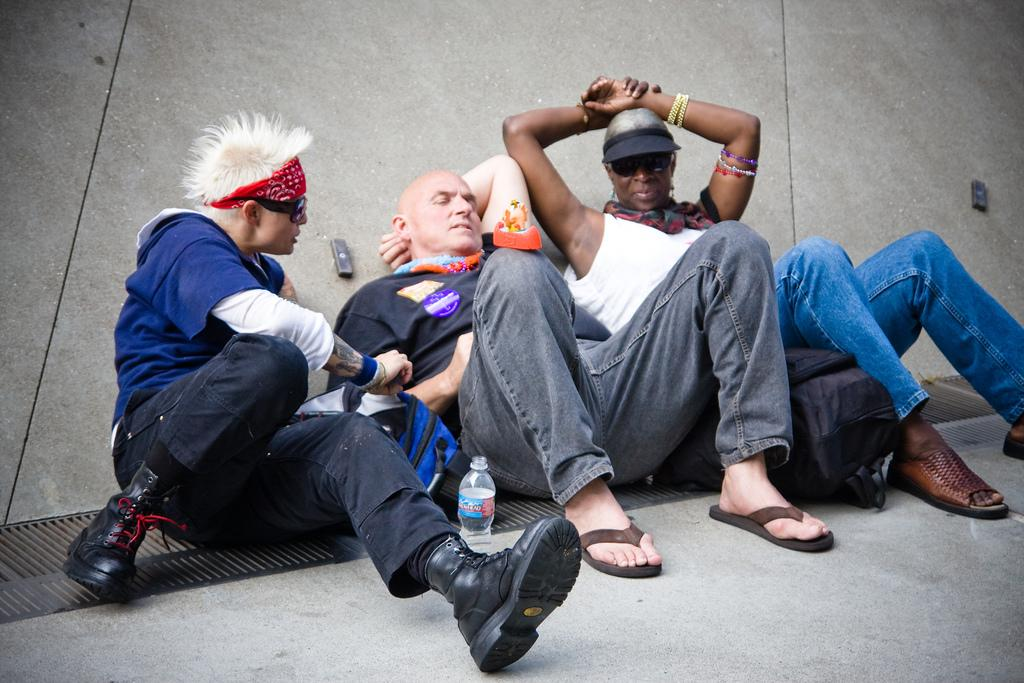How many people are present in the image? There are three people in the image. What can be seen on the path in the image? There is a bag and a bottle on the path. What type of vessel is being used by one of the people in the image? There is no vessel being used by any of the people in the image. 